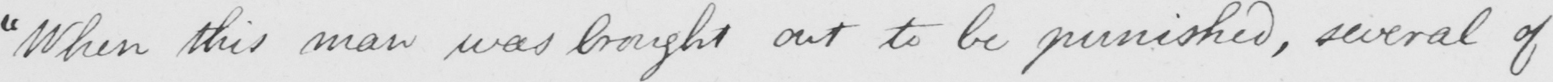Please provide the text content of this handwritten line. " When this man was brought out to be punished , several of 